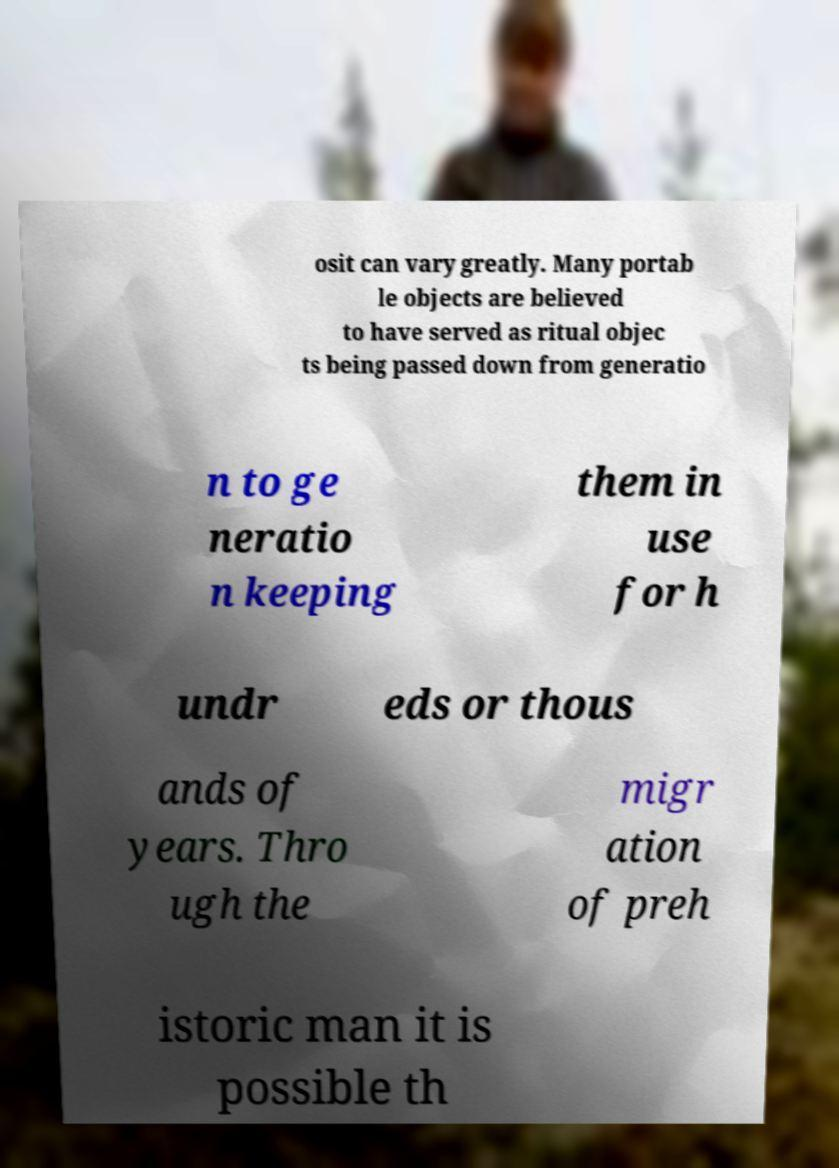I need the written content from this picture converted into text. Can you do that? osit can vary greatly. Many portab le objects are believed to have served as ritual objec ts being passed down from generatio n to ge neratio n keeping them in use for h undr eds or thous ands of years. Thro ugh the migr ation of preh istoric man it is possible th 